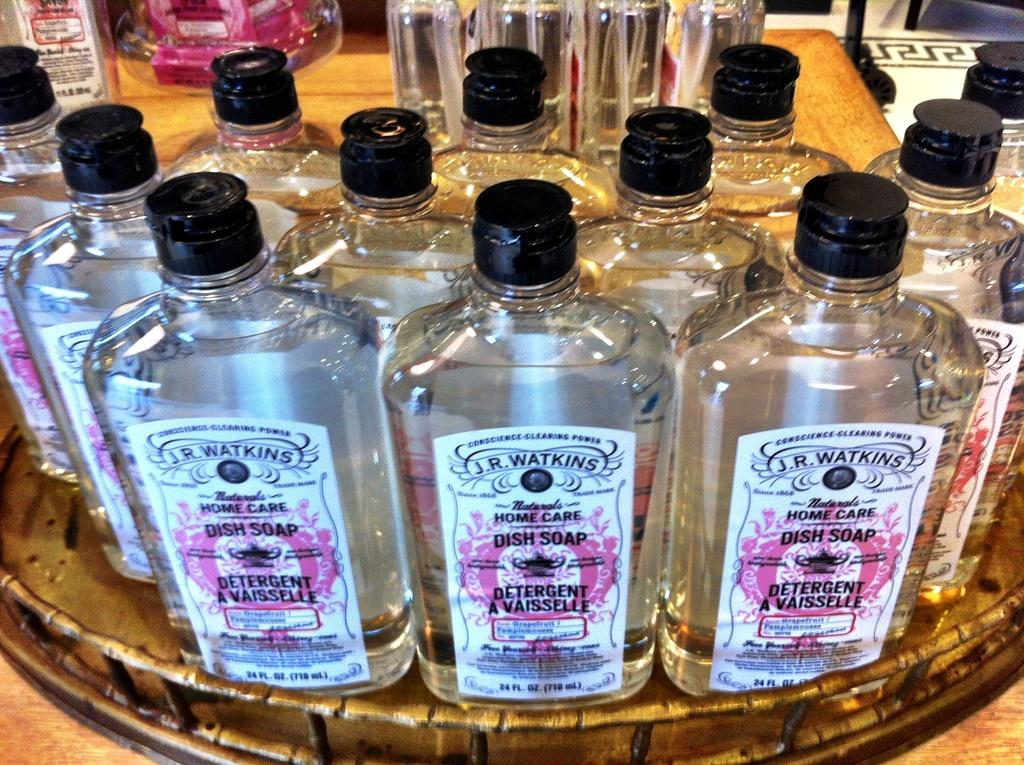Provide a one-sentence caption for the provided image. A close up image of a display of J.R. Watkins dish soap. 